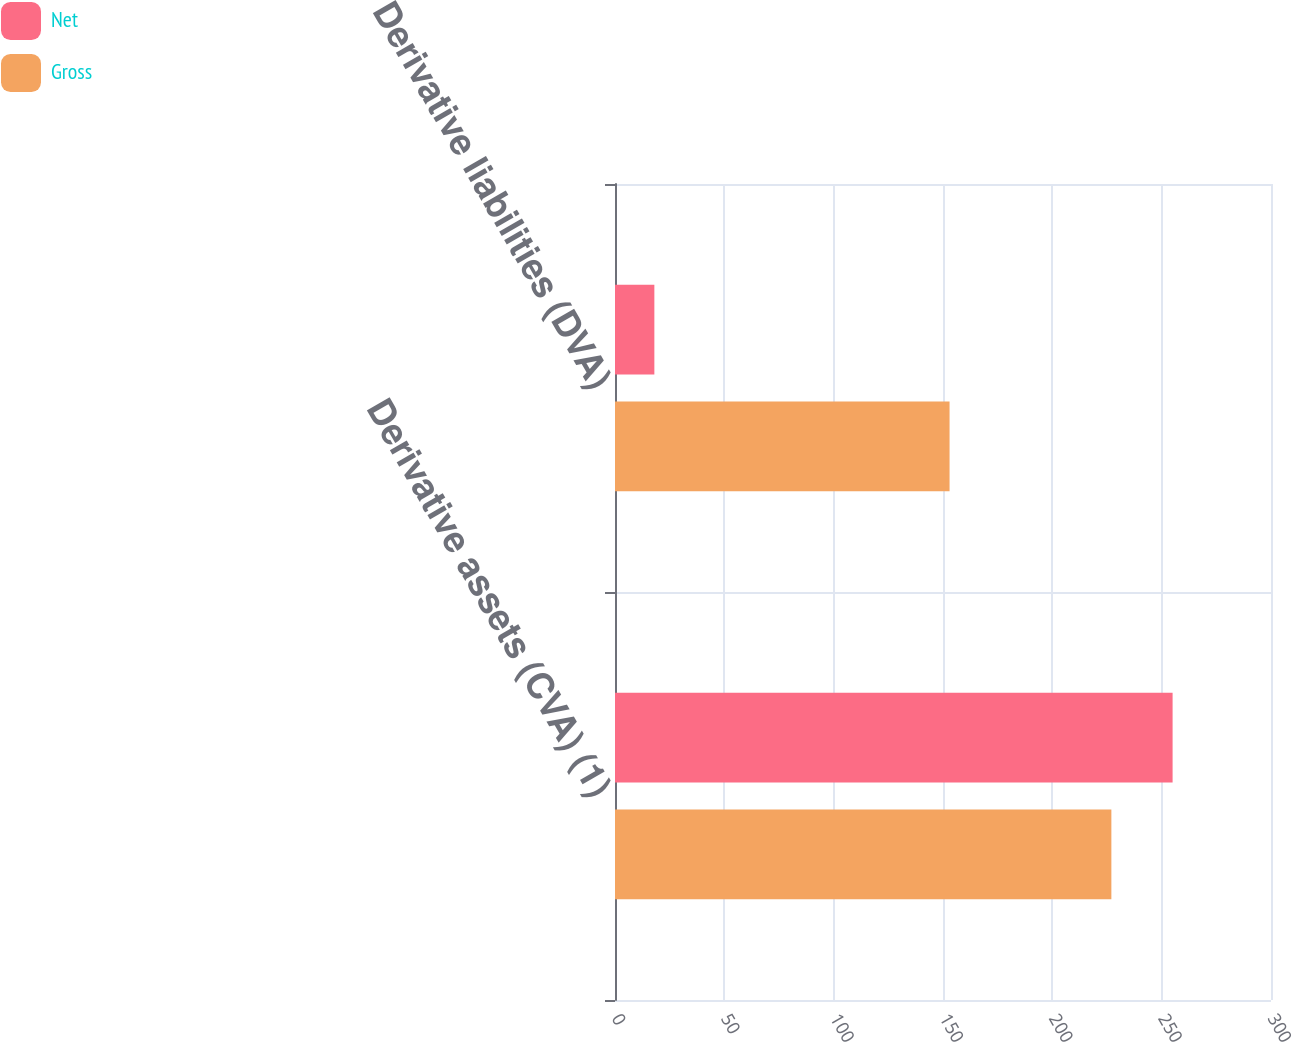Convert chart to OTSL. <chart><loc_0><loc_0><loc_500><loc_500><stacked_bar_chart><ecel><fcel>Derivative assets (CVA) (1)<fcel>Derivative liabilities (DVA)<nl><fcel>Net<fcel>255<fcel>18<nl><fcel>Gross<fcel>227<fcel>153<nl></chart> 